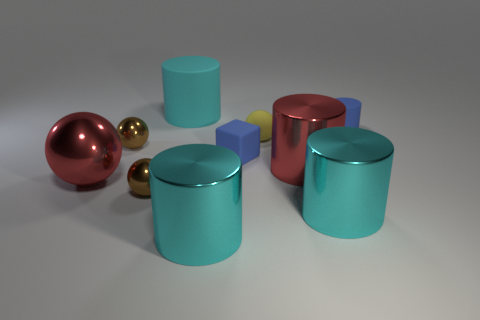How many objects are there in total, and can you describe their colors? There are a total of eight objects in the image, consisting of various colors: one large red sphere, two smaller golden spheres, two teal-colored cylinders, one rose-colored cylinder, and two smaller geometric shapes that appear to be cubes, one blue and one purple. 